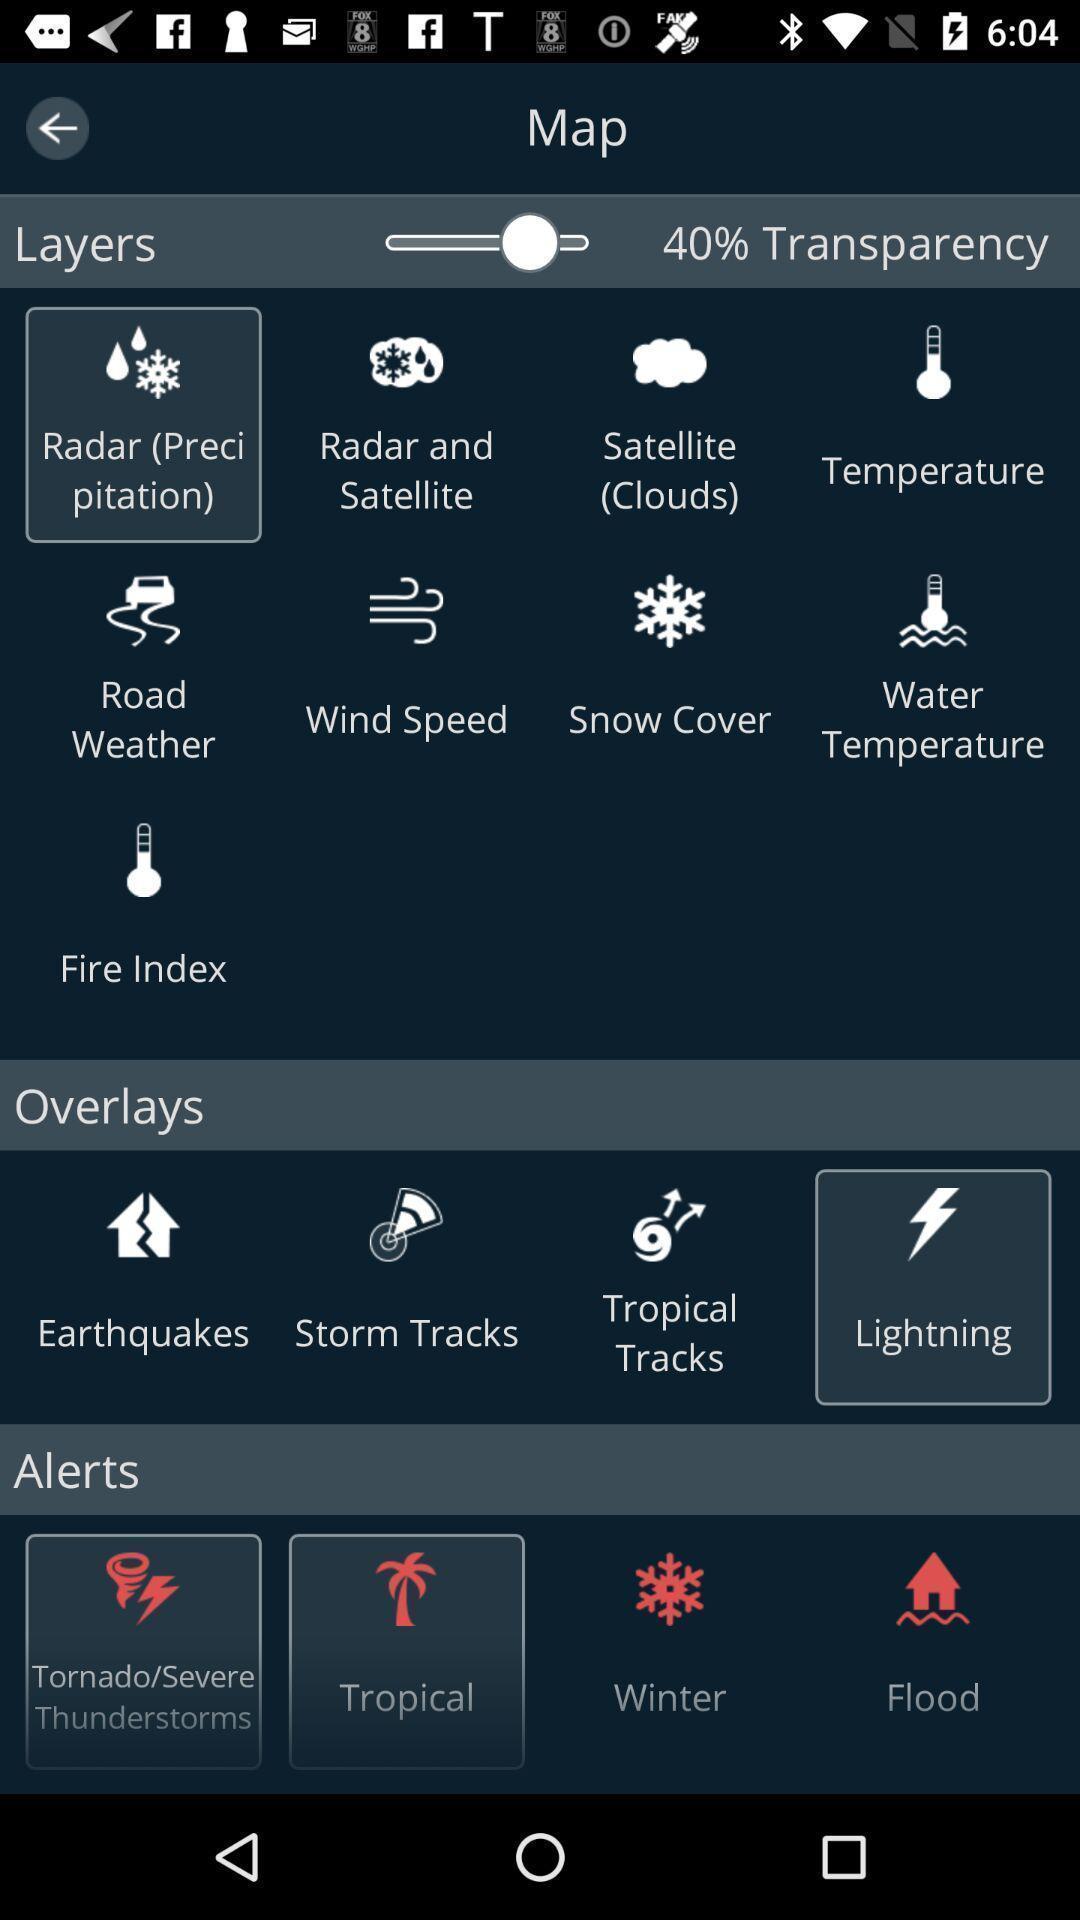What is the overall content of this screenshot? Page displays multiple options. 